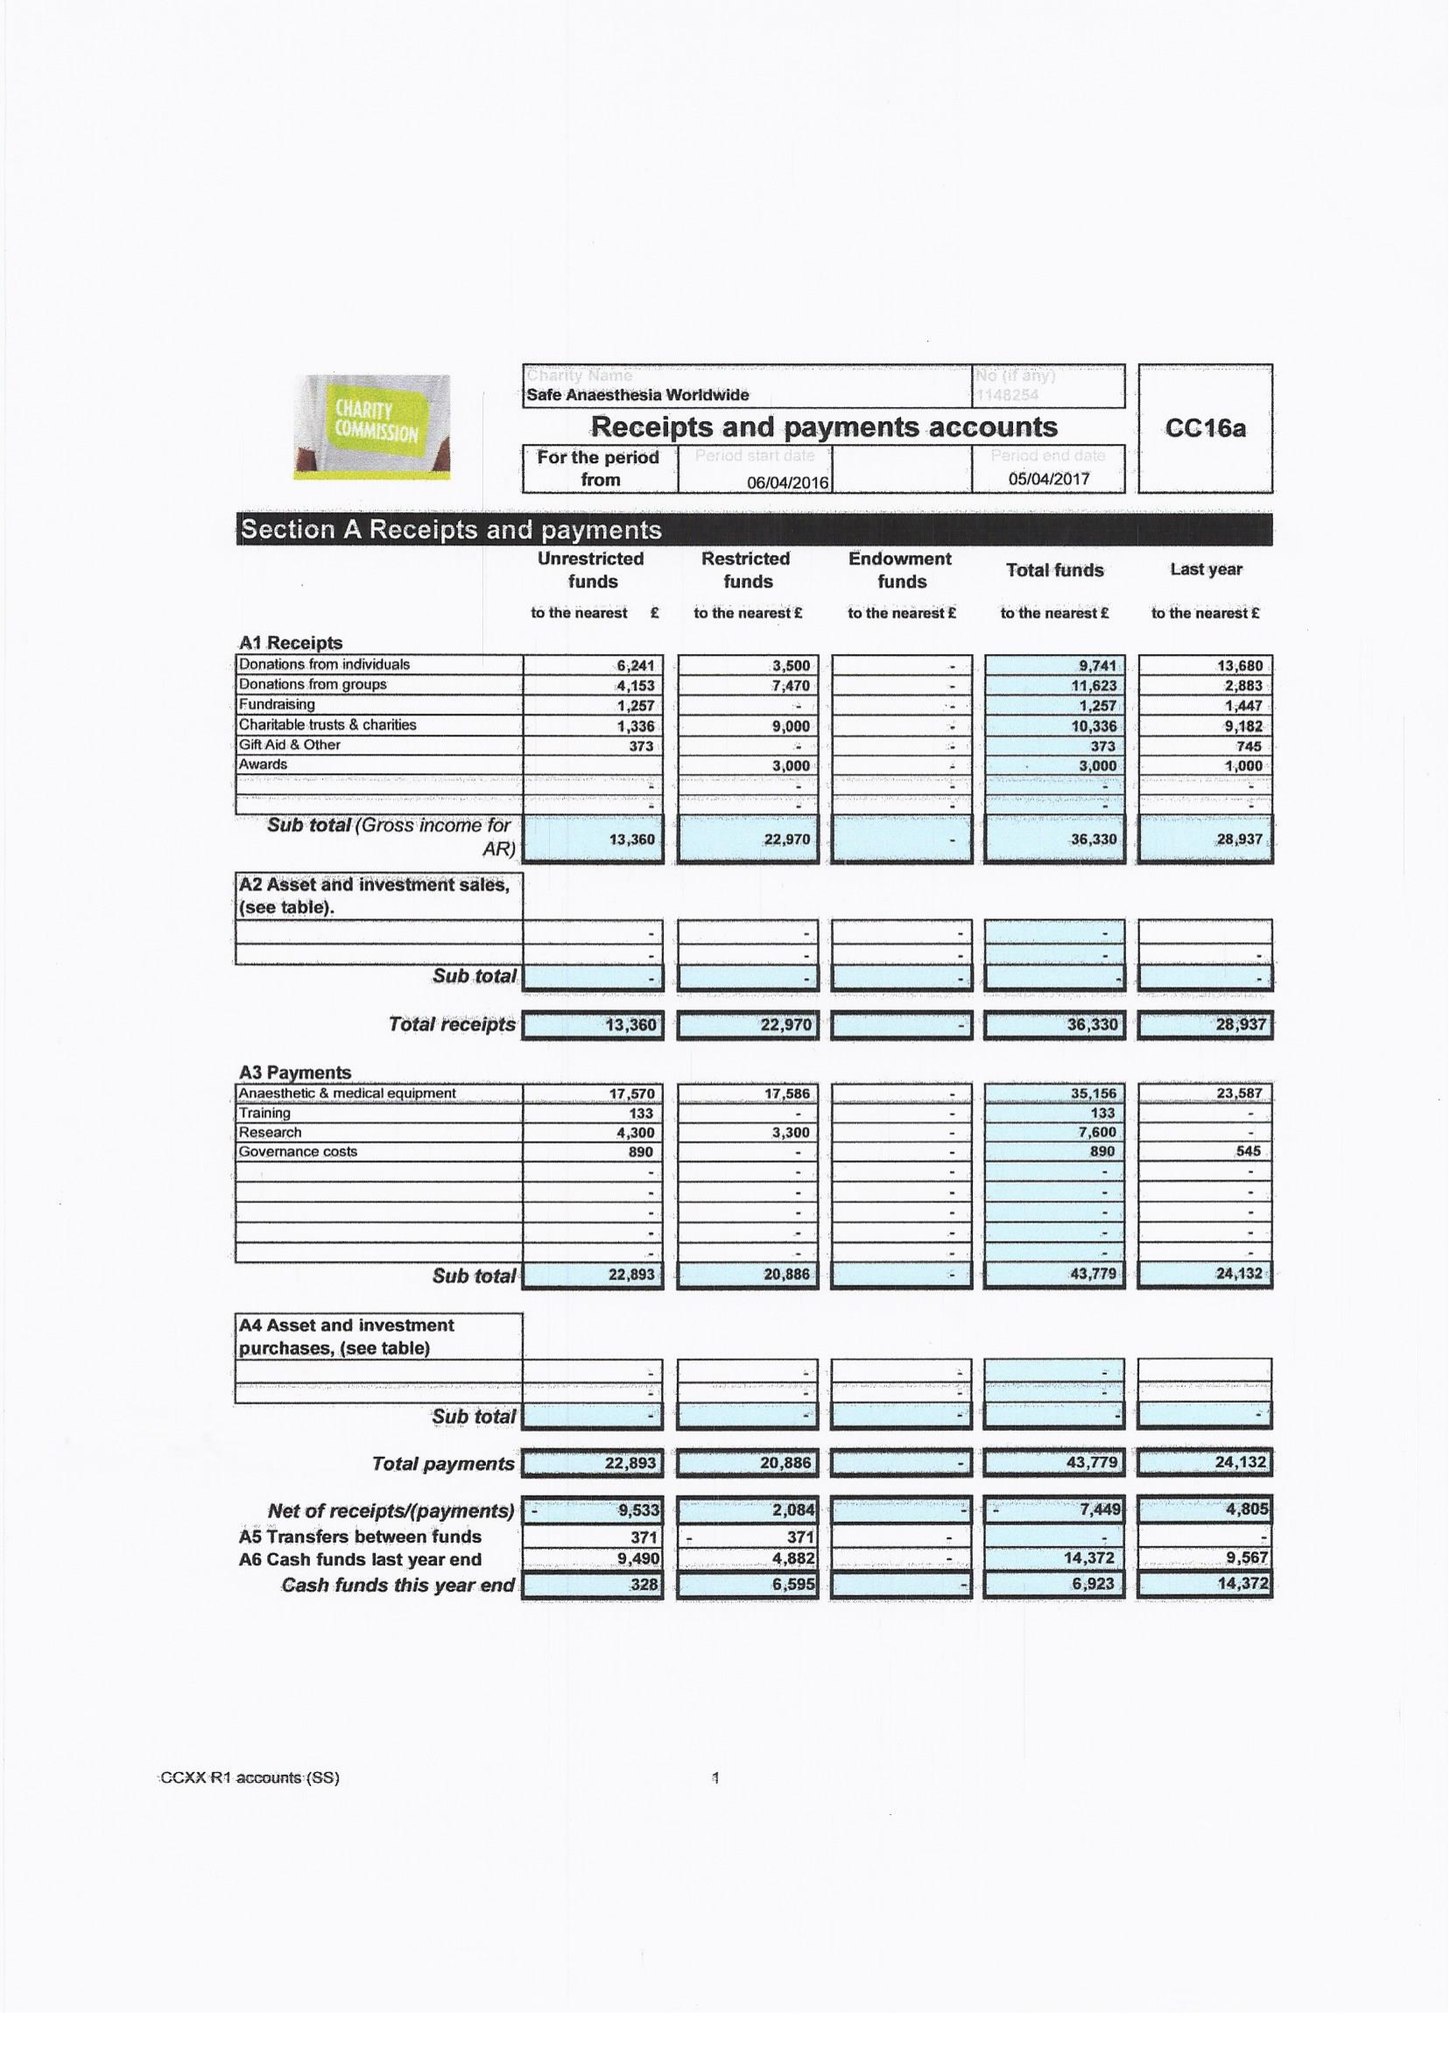What is the value for the address__postcode?
Answer the question using a single word or phrase. TN12 9DR 